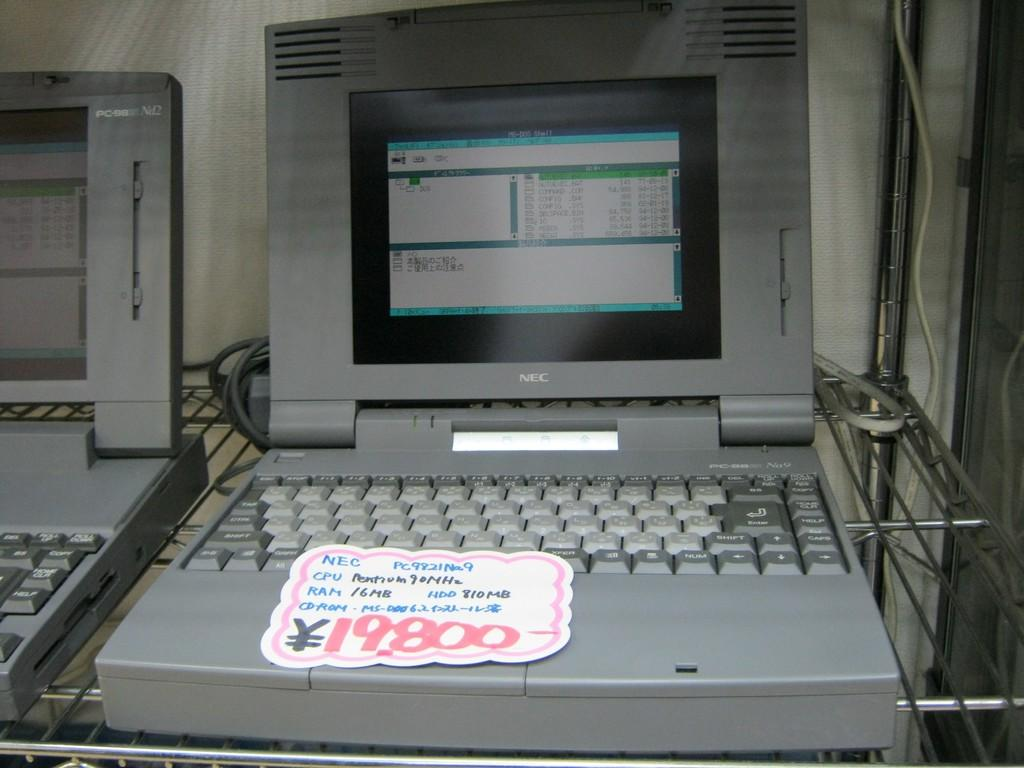<image>
Share a concise interpretation of the image provided. the price of 19800 is on the front of the laptop 